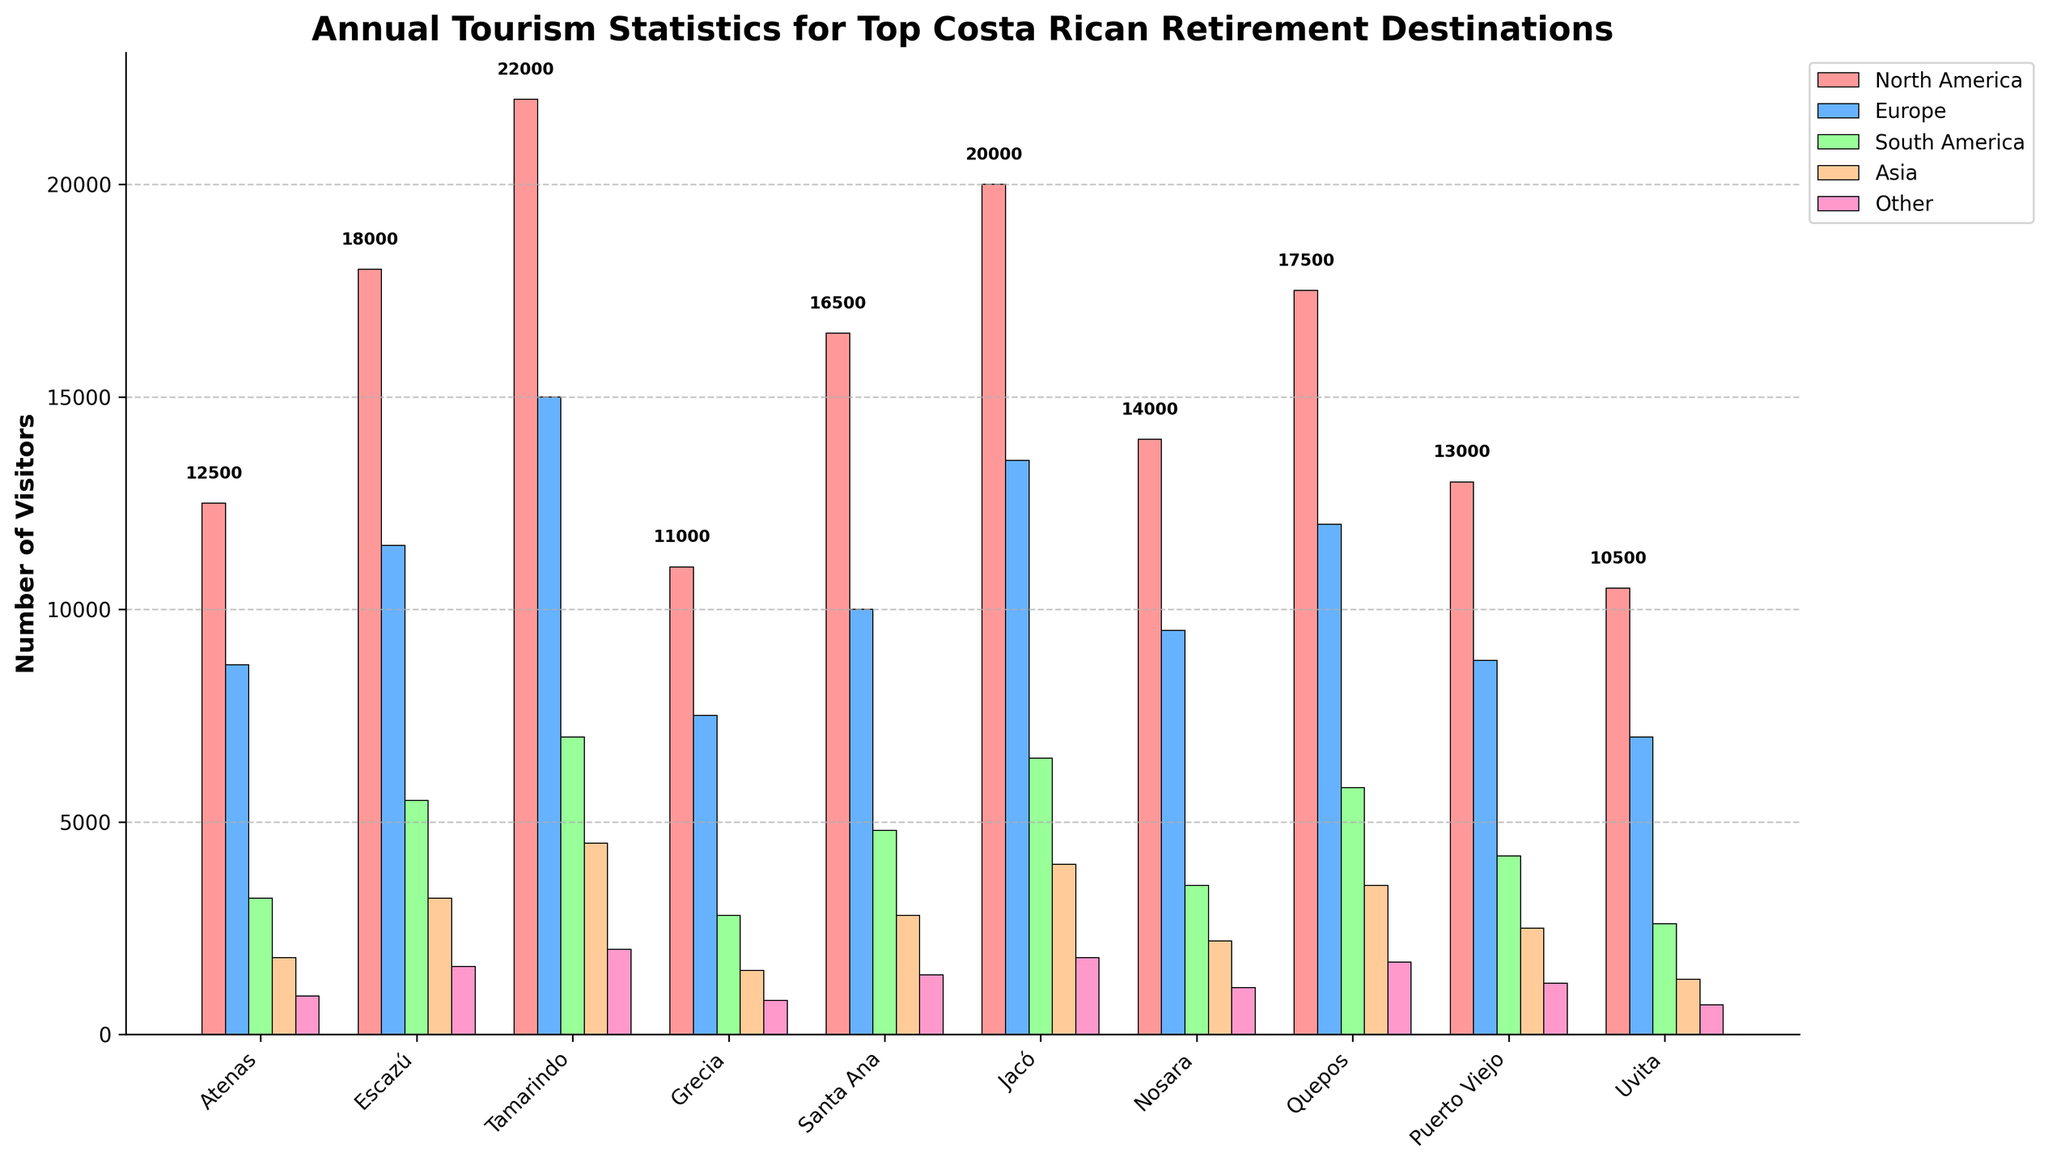Which location receives the highest number of visitors from North America? By looking at the height of the bars colored for North America, we can see that Tamarindo has the tallest bar in this category with 22,000 visitors.
Answer: Tamarindo Compare the number of European visitors in Atenas and Puerto Viejo. Which location attracts more European tourists? The bars for Europe show Atenas with 8,700 visitors and Puerto Viejo with 8,800 visitors.
Answer: Puerto Viejo What is the total number of visitors from South America to Escazú and Jacó? Adding the numbers from the South America category for Escazú (5,500) and Jacó (6,500) gives a total of 12,000 visitors.
Answer: 12,000 Which location experiences the least number of visitors from Asia? By observing the bars colored for Asia, the smallest bar is for Uvita, with 1,300 visitors.
Answer: Uvita What is the average number of visitors from Europe across all locations? Sum up all the visitors from Europe: 8,700 + 11,500 + 15,000 + 7,500 + 10,000 + 13,500 + 9,500 + 12,000 + 8,800 + 7,000 = 103,500. Then, divide by the number of locations, 10: 103,500 / 10 = 10,350 visitors on average.
Answer: 10,350 How many more visitors does Jacó receive from North America than Nosara does? Subtract the North American visitors in Nosara (14,000) from those in Jacó (20,000), 20,000 - 14,000 = 6,000.
Answer: 6,000 Which location has a higher combined number of visitors from South America and Asia, Santa Ana or Grecia? For Santa Ana, South America: 4,800 and Asia: 2,800. Combined, that's 7,600. For Grecia, South America: 2,800 and Asia: 1,500. Combined, that's 4,300. Santa Ana has more combined visitors.
Answer: Santa Ana Among all the locations, which one has the tallest bar in the 'Other' visitor category? The tallest bar for 'Other' visitors is found in Tamarindo with 2,000 visitors.
Answer: Tamarindo How does the number of European visitors to Nosara compare to those from North America to Atenas? For Nosara, there are 9,500 European visitors while Atenas has 12,500 visitors from North America. Comparing, North American visitors to Atenas outnumber European visitors to Nosara.
Answer: North America to Atenas Which location has the smallest disparity in visitor numbers between North America and Asia? Calculate the difference for each location and look for the smallest difference. Atenas: 12,500 - 1,800 = 10,700, Escazú: 18,000 - 3,200 = 14,800, Tamarindo: 22,000 - 4,500 = 17,500, Grecia: 11,000 - 1,500 = 9,500, Santa Ana: 16,500 - 2,800 = 13,700, Jacó: 20,000 - 4,000 = 16,000, Nosara: 14,000 - 2,200 = 11,800, Quepos: 17,500 - 3,500 = 14,000, Puerto Viejo: 13,000 - 2,500 = 10,500, and Uvita: 10,500 - 1,300 = 9,200. Grecia has the smallest disparity with 9,500.
Answer: Grecia 